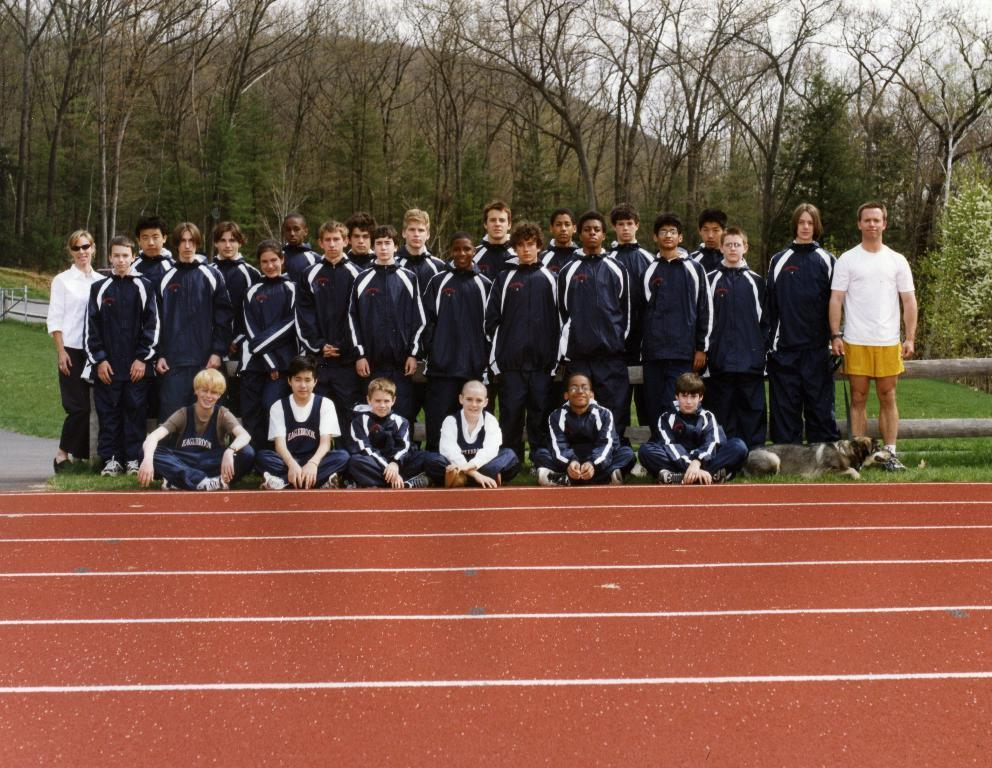What are the people in the image doing? Some people are standing, and some are sitting in the image. Can you describe the background of the image? There are trees in the background of the image. How many babies are holding the flag in the image? There is no flag or babies present in the image. 